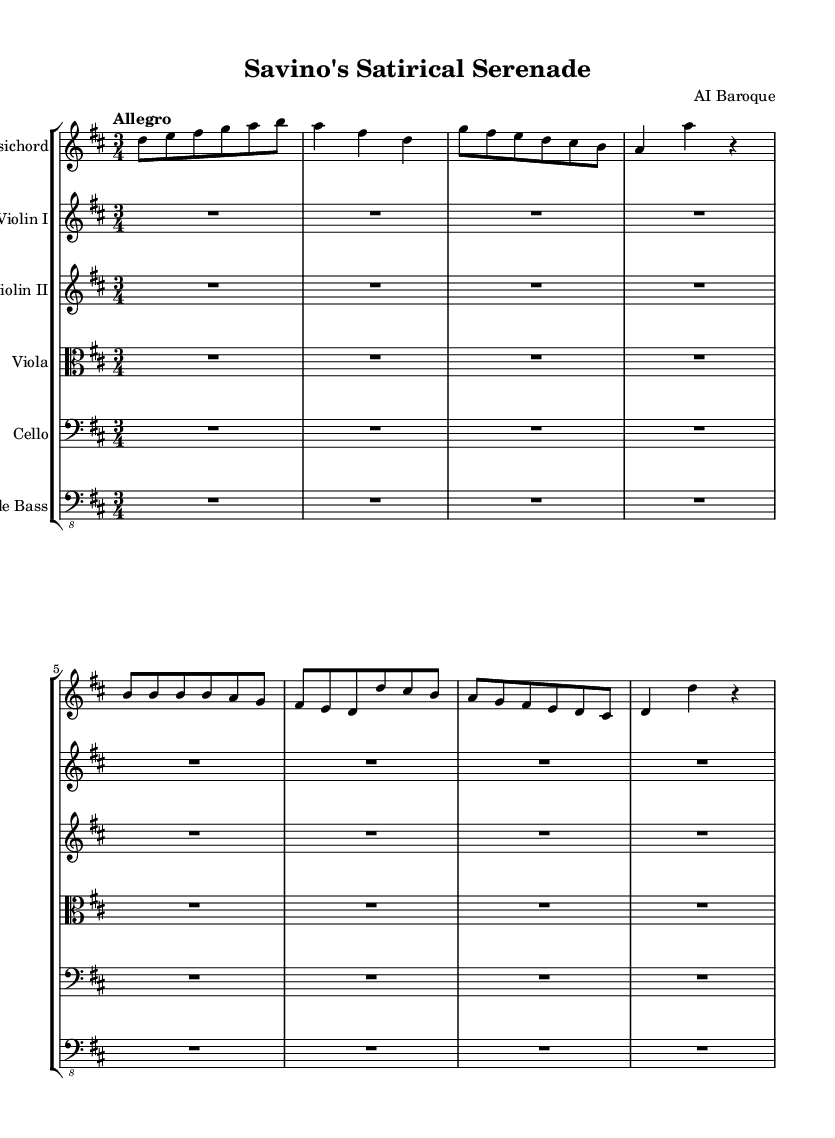What is the key signature of this music? The key signature indicated is D major, which has two sharps (F# and C#). This is determined by looking for the sharps or flats at the beginning of the staff.
Answer: D major What is the time signature of this music? The time signature shown is 3/4, which signifies three beats per measure and that a quarter note gets one beat. This can be identified in the notation after the key signature.
Answer: 3/4 What is the tempo marking for this piece? The tempo marking states "Allegro", indicating a fast and lively pace, which is common in this style of music. It is displayed at the beginning of the musical score.
Answer: Allegro How many measures are in the provided harpsichord part? The harpsichord section contains 8 measures, as indicated by the grouping of musical notes divided into bars or measures. Each measure is separated by a vertical line.
Answer: 8 What instruments are used in this piece? The listed instruments are solo harpsichord, violin I, violin II, viola, cello, and double bass. These are identified by the instrument names above each staff in the score.
Answer: Harpsichord, violins, viola, cello, double bass What is the texture of the music? The texture can be described as polyphonic, where multiple independent melodies are played simultaneously, typical of Baroque music, which involves interactions among the instruments.
Answer: Polyphonic What is the main theme depicted in the harpsichord part? The main theme presents witty and humorous motifs, reflective of a light-hearted, comedic style very much in line with Savino's own approach, showcased in the playful rhythms and melodic lines.
Answer: Witty and humorous themes 